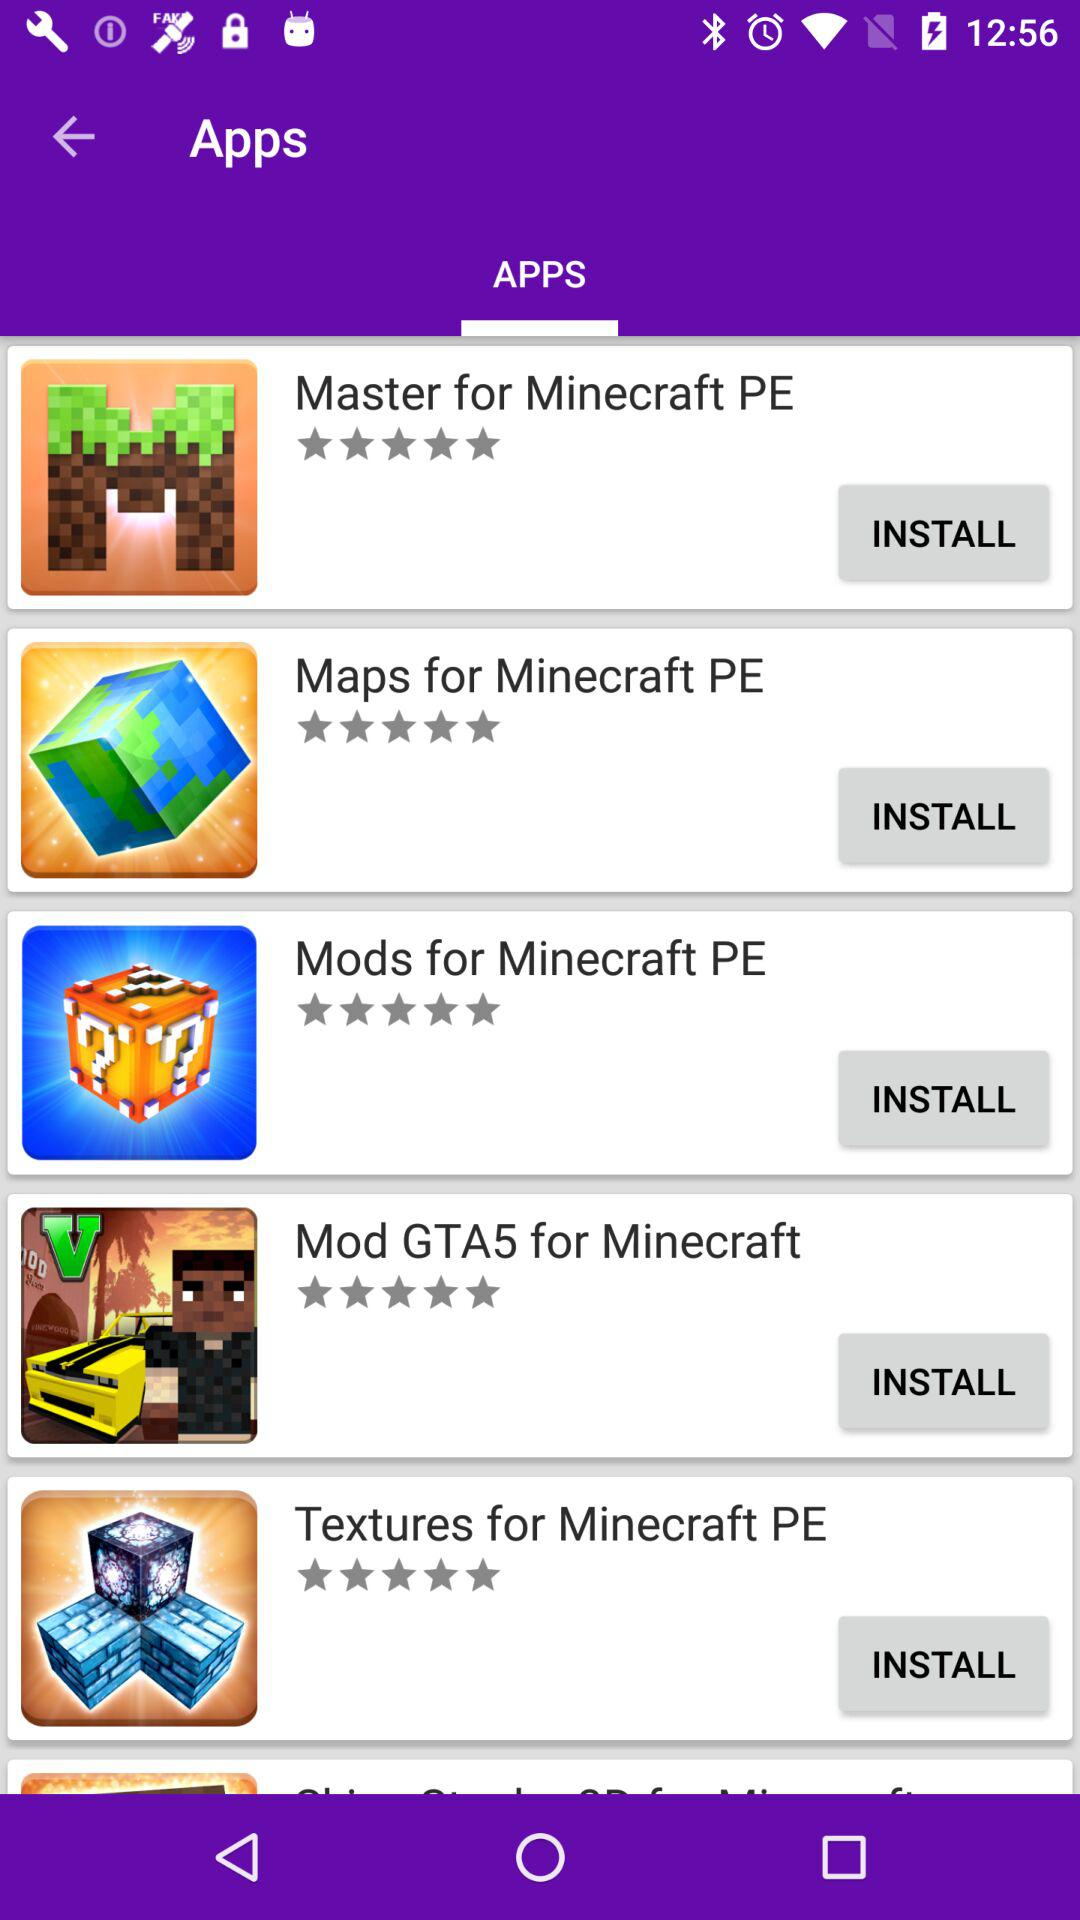How many maps are there for Minecraft PE?
When the provided information is insufficient, respond with <no answer>. <no answer> 